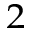<formula> <loc_0><loc_0><loc_500><loc_500>^ { 2 }</formula> 